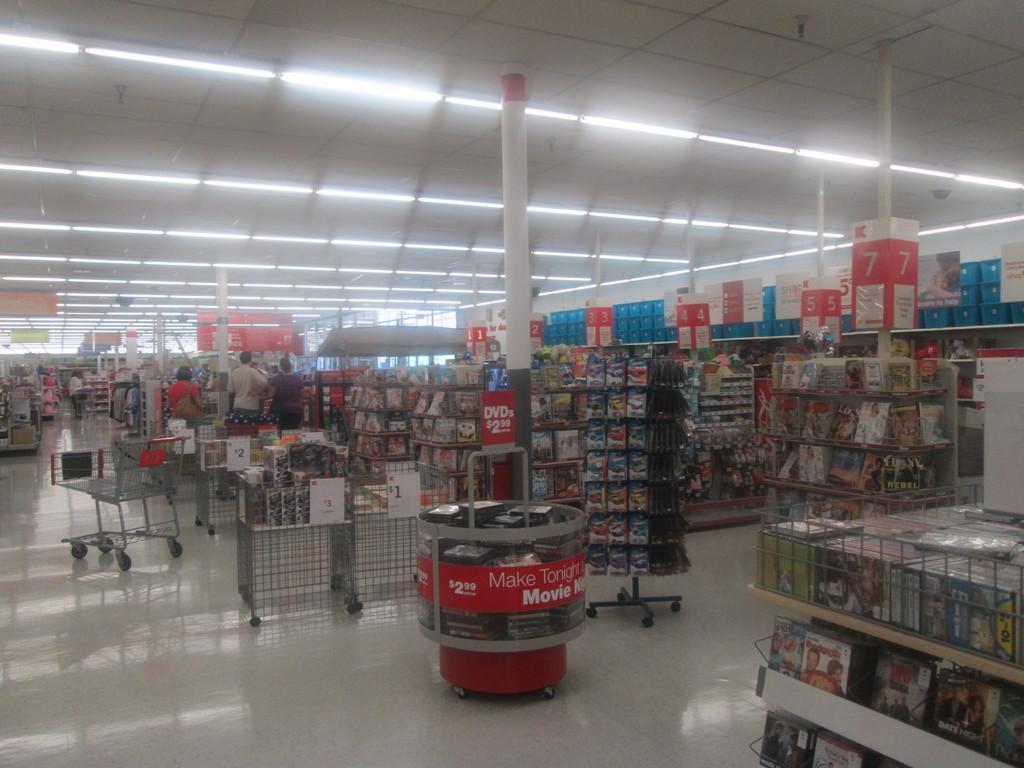Describe this image in one or two sentences. There are book racks, trolleys and people in the foreground area of the image and lamps at the top side, it seems like a book store. 